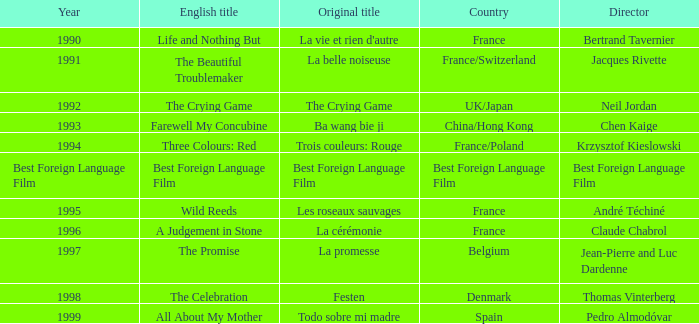Who is the Director of the Original title of The Crying Game? Neil Jordan. 